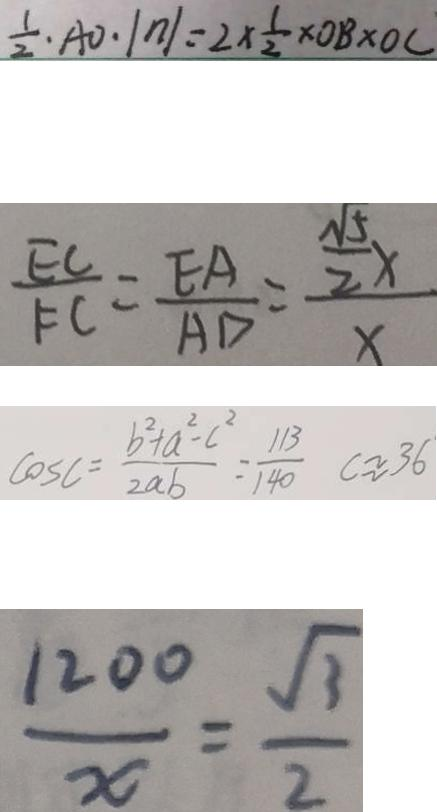<formula> <loc_0><loc_0><loc_500><loc_500>\frac { 1 } { 2 } \cdot A O \cdot \vert n \vert = 2 \times \frac { 1 } { 2 } \times O B \times O C 
 \frac { E C } { F C } = \frac { E A } { A D } = \frac { \frac { \sqrt { 5 } } { 2 } x } { x } 
 \cos C = \frac { b ^ { 2 } + a ^ { 2 } - c ^ { 2 } } { 2 a b } = \frac { 1 1 3 } { 1 4 0 } c \approx 3 6 
 \frac { 1 2 0 0 } { x } = \frac { \sqrt { 3 } } { 2 }</formula> 